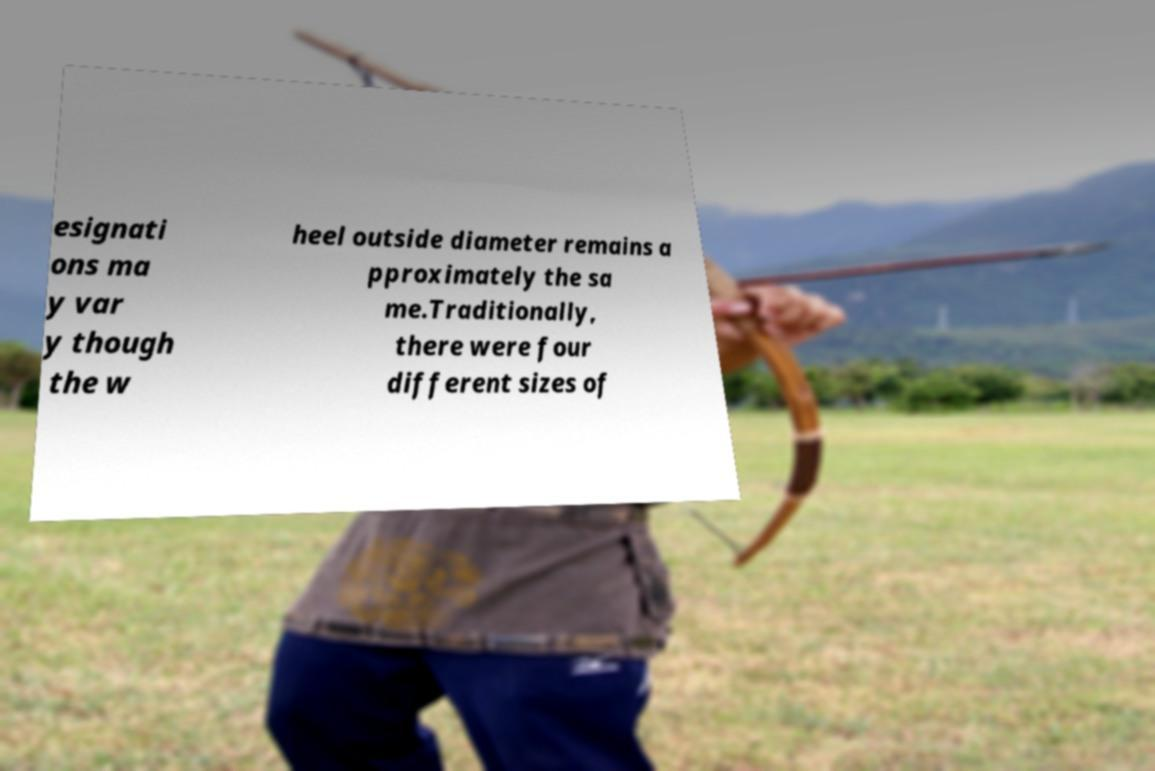Can you accurately transcribe the text from the provided image for me? esignati ons ma y var y though the w heel outside diameter remains a pproximately the sa me.Traditionally, there were four different sizes of 